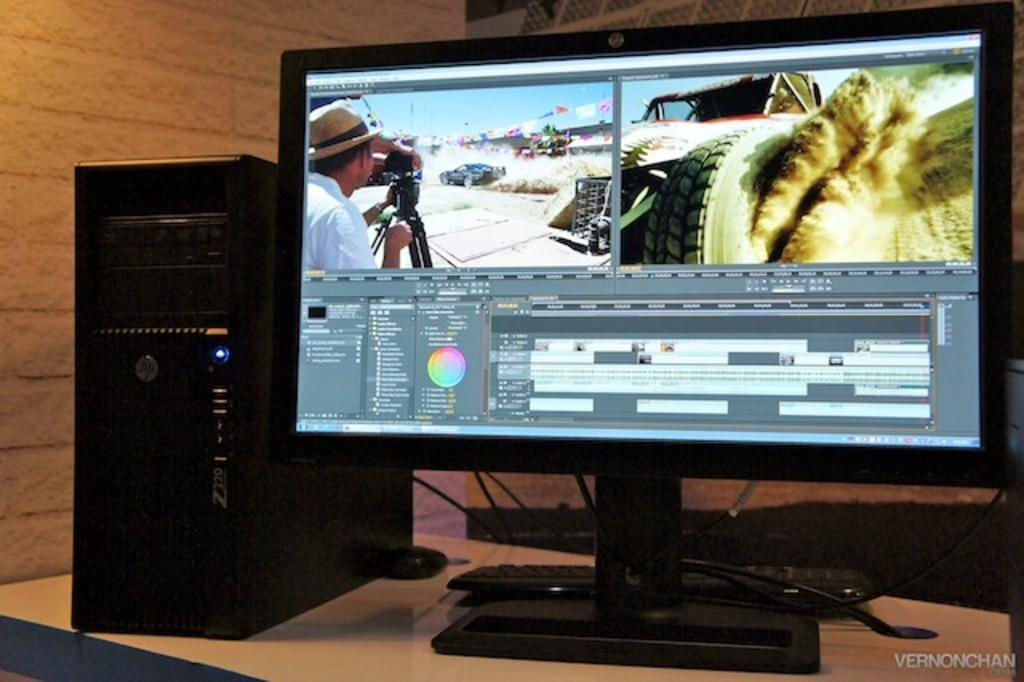<image>
Write a terse but informative summary of the picture. a computer that has the letters HP on it 